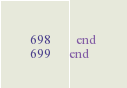Convert code to text. <code><loc_0><loc_0><loc_500><loc_500><_Ruby_>
  end
end
</code> 